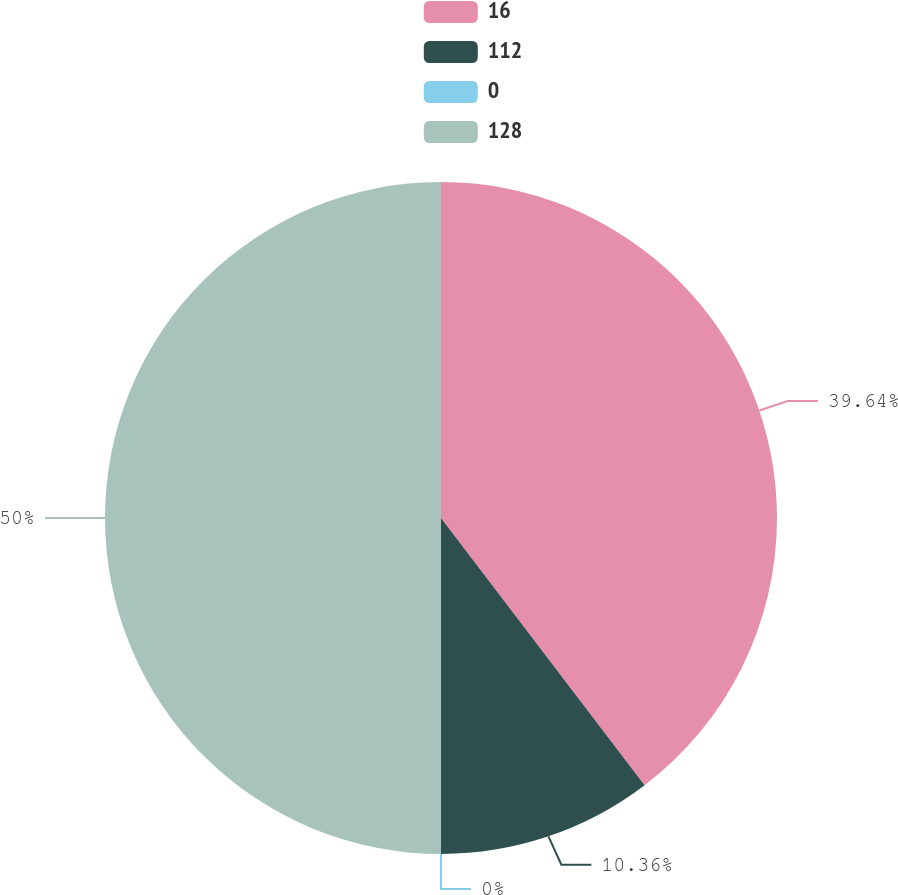<chart> <loc_0><loc_0><loc_500><loc_500><pie_chart><fcel>16<fcel>112<fcel>0<fcel>128<nl><fcel>39.64%<fcel>10.36%<fcel>0.0%<fcel>50.0%<nl></chart> 